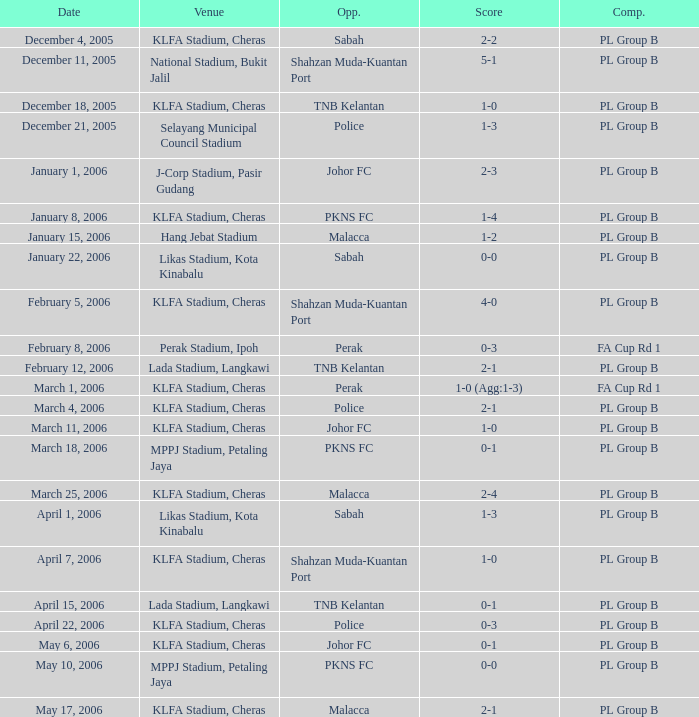Which Venue has a Competition of pl group b, and a Score of 2-2? KLFA Stadium, Cheras. 